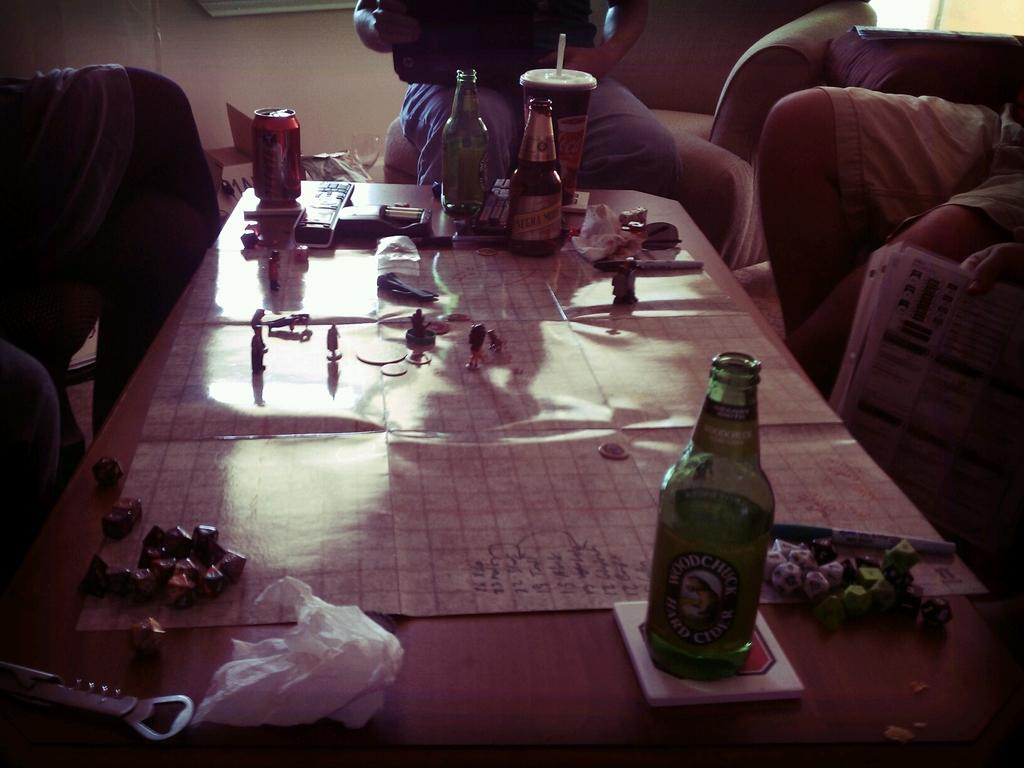What is one of the objects visible in the image? There is a bottle in the image. What else can be seen in the image besides the bottle? There are food items, a fork, cigarettes, a remote, and a coke tin in the image. What type of utensil is present in the image? There is a fork in the image. What type of beverage container is present in the image? There is a coke tin in the image. Where are the objects located in the image? The objects are on top of a table. Are there any people visible in the image? Yes, there are two persons sitting in the background of the image. What type of apparel is the person wearing on their toe in the image? There is no person wearing apparel on their toe in the image. What type of swim gear is visible in the image? There is no swim gear present in the image. 